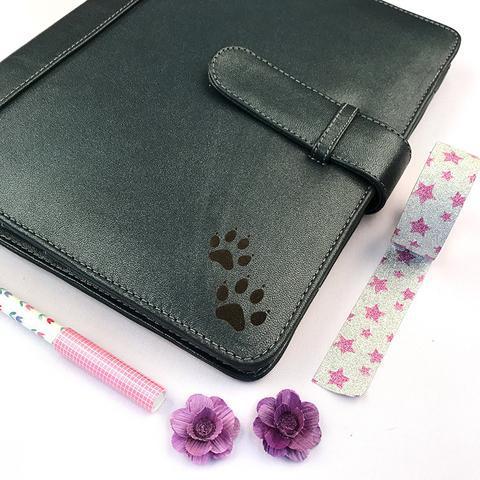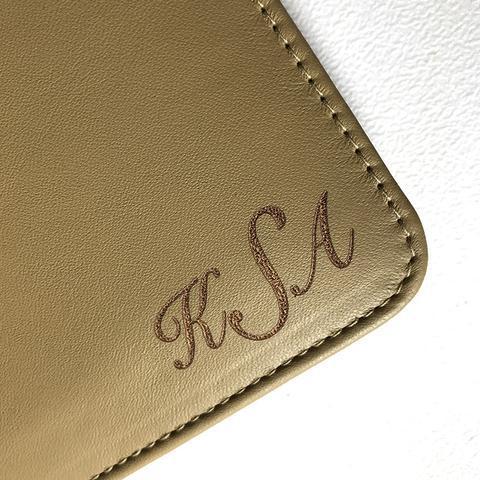The first image is the image on the left, the second image is the image on the right. For the images displayed, is the sentence "One image shows exactly one open orange binder." factually correct? Answer yes or no. No. The first image is the image on the left, the second image is the image on the right. Examine the images to the left and right. Is the description "One of the binders is gold." accurate? Answer yes or no. Yes. The first image is the image on the left, the second image is the image on the right. Considering the images on both sides, is "In one image, a peach colored notebook is shown in an open position, displaying its contents." valid? Answer yes or no. No. 